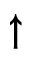Convert formula to latex. <formula><loc_0><loc_0><loc_500><loc_500>\uparrow</formula> 